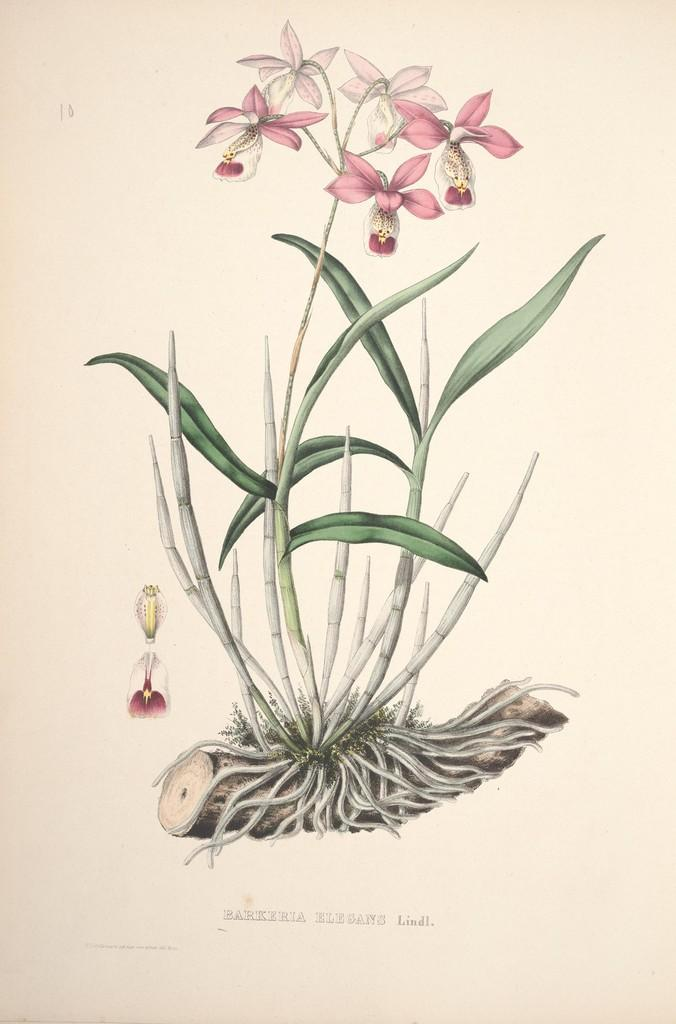What is depicted in the image? There is a sketch of a plant in the image. What features can be observed on the plant? The plant has flowers and roots on the trunk. Is there any text associated with the sketch? Yes, there is text below the sketch. Where is the kite being flown in the image? There is no kite present in the image; it only features a sketch of a plant with text below it. 